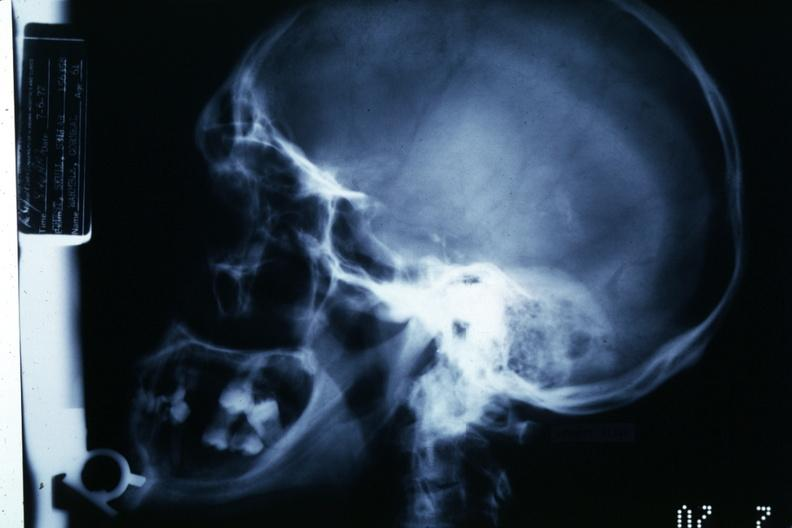what is present?
Answer the question using a single word or phrase. Chromophobe adenoma 